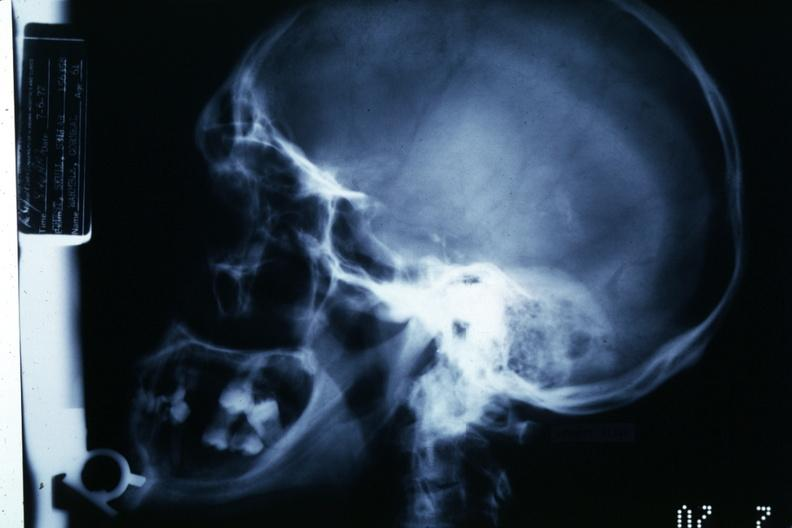what is present?
Answer the question using a single word or phrase. Chromophobe adenoma 